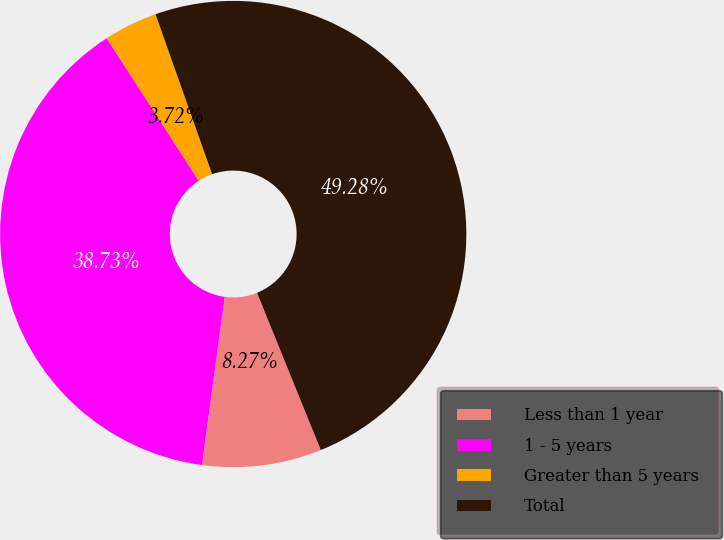Convert chart to OTSL. <chart><loc_0><loc_0><loc_500><loc_500><pie_chart><fcel>Less than 1 year<fcel>1 - 5 years<fcel>Greater than 5 years<fcel>Total<nl><fcel>8.27%<fcel>38.73%<fcel>3.72%<fcel>49.28%<nl></chart> 